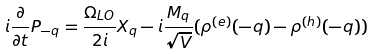Convert formula to latex. <formula><loc_0><loc_0><loc_500><loc_500>i \frac { \partial } { \partial t } P _ { - { q } } = \frac { \Omega _ { L O } } { 2 i } X _ { q } - i \frac { M _ { q } } { { \sqrt { V } } } ( \rho ^ { ( e ) } ( - { q } ) - \rho ^ { ( h ) } ( - { q } ) )</formula> 